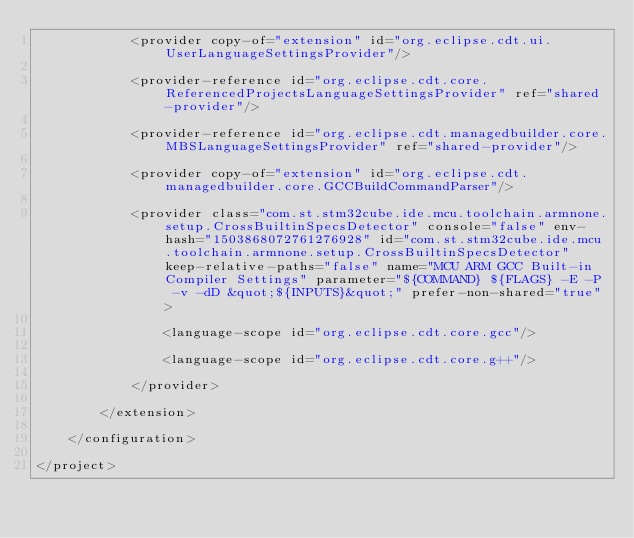Convert code to text. <code><loc_0><loc_0><loc_500><loc_500><_XML_>            <provider copy-of="extension" id="org.eclipse.cdt.ui.UserLanguageSettingsProvider"/>
            			
            <provider-reference id="org.eclipse.cdt.core.ReferencedProjectsLanguageSettingsProvider" ref="shared-provider"/>
            			
            <provider-reference id="org.eclipse.cdt.managedbuilder.core.MBSLanguageSettingsProvider" ref="shared-provider"/>
            			
            <provider copy-of="extension" id="org.eclipse.cdt.managedbuilder.core.GCCBuildCommandParser"/>
            			
            <provider class="com.st.stm32cube.ide.mcu.toolchain.armnone.setup.CrossBuiltinSpecsDetector" console="false" env-hash="1503868072761276928" id="com.st.stm32cube.ide.mcu.toolchain.armnone.setup.CrossBuiltinSpecsDetector" keep-relative-paths="false" name="MCU ARM GCC Built-in Compiler Settings" parameter="${COMMAND} ${FLAGS} -E -P -v -dD &quot;${INPUTS}&quot;" prefer-non-shared="true">
                				
                <language-scope id="org.eclipse.cdt.core.gcc"/>
                				
                <language-scope id="org.eclipse.cdt.core.g++"/>
                			
            </provider>
            		
        </extension>
        	
    </configuration>
    
</project>
</code> 